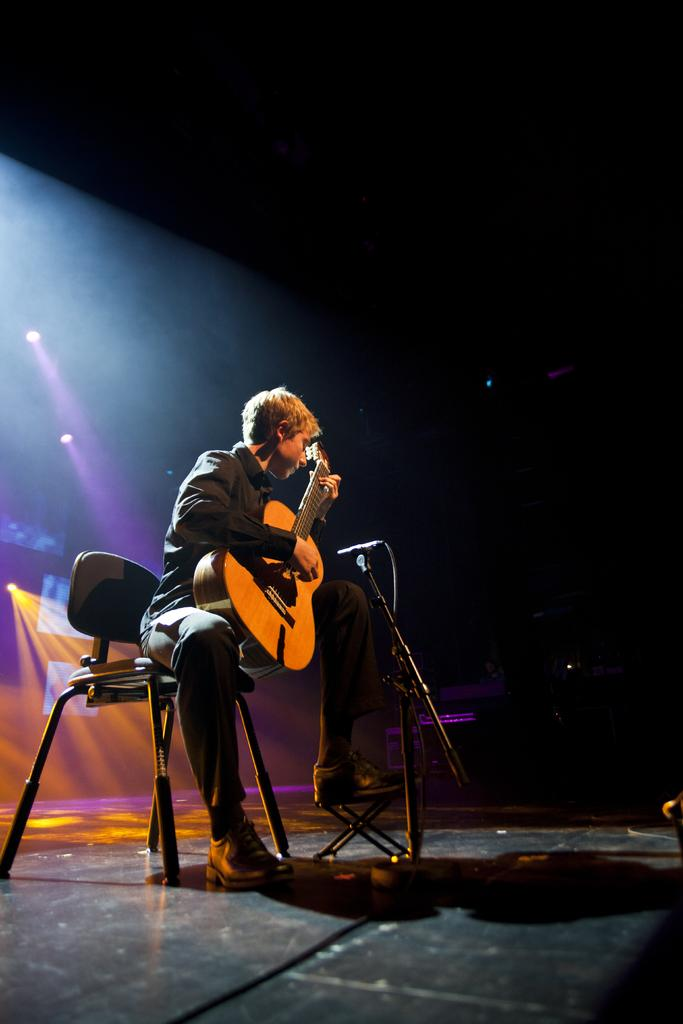What is the man in the image doing? The man is playing a guitar. What is the man sitting on in the image? The man is seated on a chair. What object is in front of the man? There is a microphone in front of the man. What can be seen in the background of the image? There are lights visible in the background of the image. What type of drum is the man holding in his hand in the image? There is no drum present in the image; the man is playing a guitar and there is a microphone in front of him. 